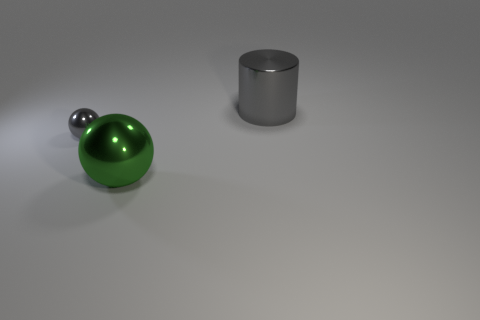Subtract all gray balls. How many balls are left? 1 Add 1 large cyan shiny things. How many objects exist? 4 Subtract 1 cylinders. How many cylinders are left? 0 Subtract all big red spheres. Subtract all small shiny spheres. How many objects are left? 2 Add 3 large metal spheres. How many large metal spheres are left? 4 Add 2 green metal things. How many green metal things exist? 3 Subtract 0 blue balls. How many objects are left? 3 Subtract all cylinders. How many objects are left? 2 Subtract all purple balls. Subtract all blue cylinders. How many balls are left? 2 Subtract all gray blocks. How many gray balls are left? 1 